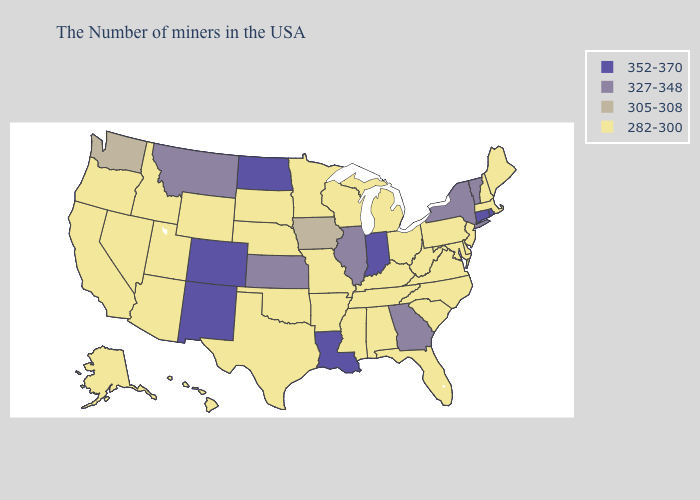Name the states that have a value in the range 352-370?
Keep it brief. Rhode Island, Connecticut, Indiana, Louisiana, North Dakota, Colorado, New Mexico. What is the value of South Dakota?
Give a very brief answer. 282-300. Name the states that have a value in the range 327-348?
Concise answer only. Vermont, New York, Georgia, Illinois, Kansas, Montana. What is the value of Utah?
Concise answer only. 282-300. What is the lowest value in the South?
Keep it brief. 282-300. Name the states that have a value in the range 282-300?
Write a very short answer. Maine, Massachusetts, New Hampshire, New Jersey, Delaware, Maryland, Pennsylvania, Virginia, North Carolina, South Carolina, West Virginia, Ohio, Florida, Michigan, Kentucky, Alabama, Tennessee, Wisconsin, Mississippi, Missouri, Arkansas, Minnesota, Nebraska, Oklahoma, Texas, South Dakota, Wyoming, Utah, Arizona, Idaho, Nevada, California, Oregon, Alaska, Hawaii. Among the states that border Maryland , which have the lowest value?
Be succinct. Delaware, Pennsylvania, Virginia, West Virginia. Does New Hampshire have the same value as Michigan?
Short answer required. Yes. What is the highest value in the MidWest ?
Concise answer only. 352-370. Name the states that have a value in the range 327-348?
Write a very short answer. Vermont, New York, Georgia, Illinois, Kansas, Montana. What is the value of Virginia?
Concise answer only. 282-300. Does South Carolina have the same value as Wyoming?
Concise answer only. Yes. Name the states that have a value in the range 305-308?
Short answer required. Iowa, Washington. Does Alabama have the same value as Virginia?
Be succinct. Yes. What is the value of New York?
Write a very short answer. 327-348. 